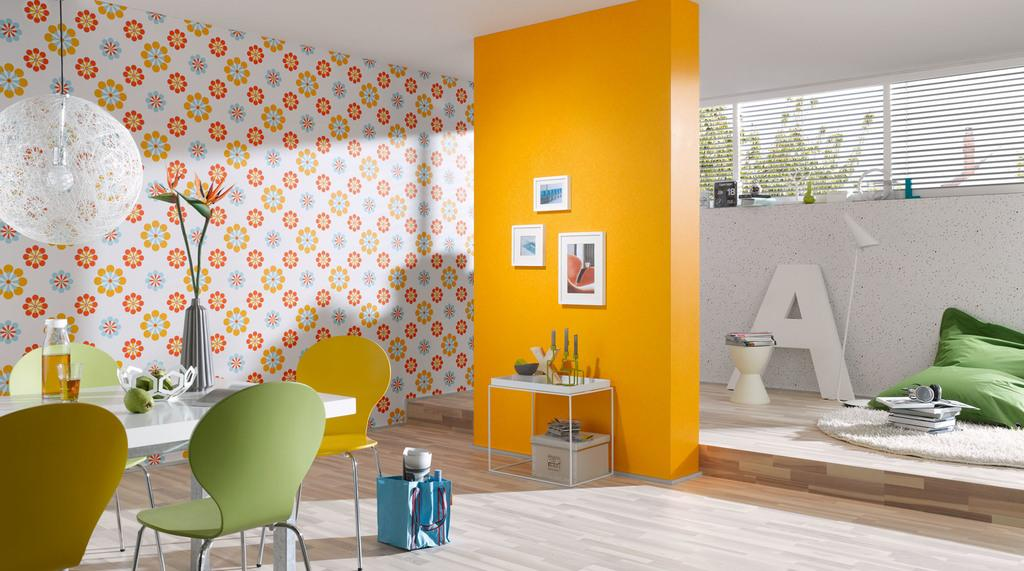What type of furniture is arranged around a central point in the room? There are chairs around a table in the room. What is another piece of furniture present in the room? There is a desk in the room. What can be found on the desk? There are things on the desk. What type of decorative items are present in the room? There are frames in the room. What is another type of seating present in the room? There is a stool in the room. Can you describe an unusual item hanging from the roof in the room? There is a lamb hanging from the roof. What type of pail is used to collect rainwater in the room? There is no pail present in the room, nor is there any mention of rainwater collection. What is the cause of the lamb hanging from the roof in the room? The provided facts do not mention the cause of the lamb hanging from the roof. 